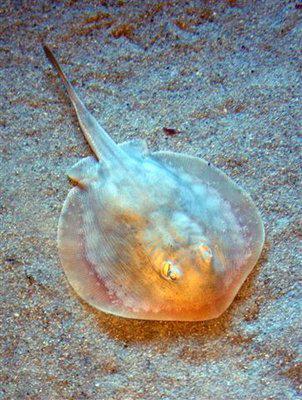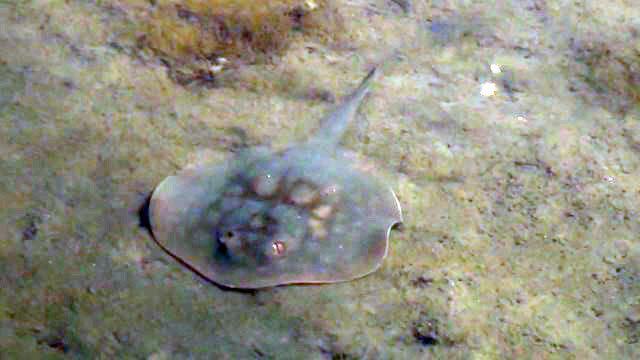The first image is the image on the left, the second image is the image on the right. Considering the images on both sides, is "All the rays are under water." valid? Answer yes or no. Yes. The first image is the image on the left, the second image is the image on the right. Analyze the images presented: Is the assertion "The left and right image contains the same number of stingrays swimming facing slightly different directions." valid? Answer yes or no. Yes. 